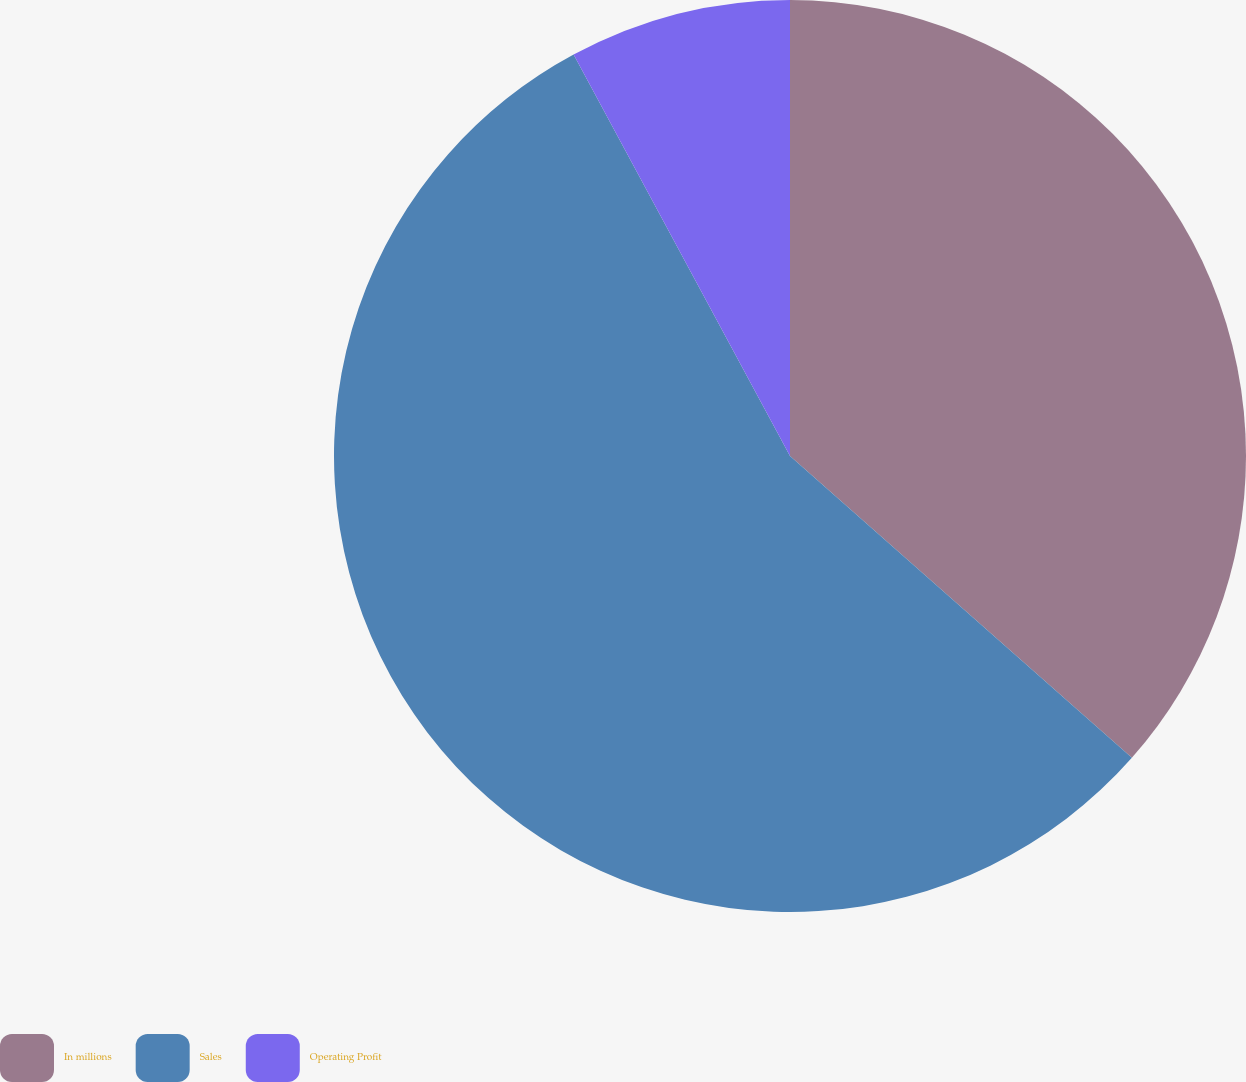<chart> <loc_0><loc_0><loc_500><loc_500><pie_chart><fcel>In millions<fcel>Sales<fcel>Operating Profit<nl><fcel>36.51%<fcel>55.62%<fcel>7.87%<nl></chart> 